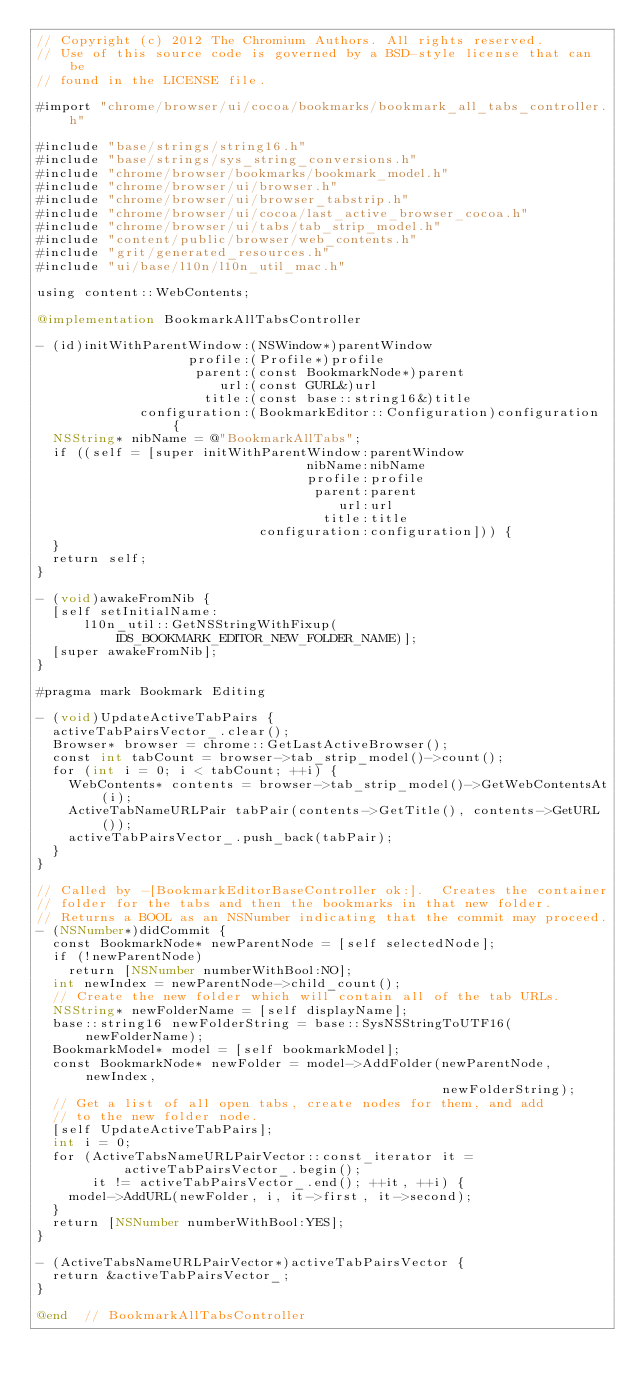<code> <loc_0><loc_0><loc_500><loc_500><_ObjectiveC_>// Copyright (c) 2012 The Chromium Authors. All rights reserved.
// Use of this source code is governed by a BSD-style license that can be
// found in the LICENSE file.

#import "chrome/browser/ui/cocoa/bookmarks/bookmark_all_tabs_controller.h"

#include "base/strings/string16.h"
#include "base/strings/sys_string_conversions.h"
#include "chrome/browser/bookmarks/bookmark_model.h"
#include "chrome/browser/ui/browser.h"
#include "chrome/browser/ui/browser_tabstrip.h"
#include "chrome/browser/ui/cocoa/last_active_browser_cocoa.h"
#include "chrome/browser/ui/tabs/tab_strip_model.h"
#include "content/public/browser/web_contents.h"
#include "grit/generated_resources.h"
#include "ui/base/l10n/l10n_util_mac.h"

using content::WebContents;

@implementation BookmarkAllTabsController

- (id)initWithParentWindow:(NSWindow*)parentWindow
                   profile:(Profile*)profile
                    parent:(const BookmarkNode*)parent
                       url:(const GURL&)url
                     title:(const base::string16&)title
             configuration:(BookmarkEditor::Configuration)configuration {
  NSString* nibName = @"BookmarkAllTabs";
  if ((self = [super initWithParentWindow:parentWindow
                                  nibName:nibName
                                  profile:profile
                                   parent:parent
                                      url:url
                                    title:title
                            configuration:configuration])) {
  }
  return self;
}

- (void)awakeFromNib {
  [self setInitialName:
      l10n_util::GetNSStringWithFixup(IDS_BOOKMARK_EDITOR_NEW_FOLDER_NAME)];
  [super awakeFromNib];
}

#pragma mark Bookmark Editing

- (void)UpdateActiveTabPairs {
  activeTabPairsVector_.clear();
  Browser* browser = chrome::GetLastActiveBrowser();
  const int tabCount = browser->tab_strip_model()->count();
  for (int i = 0; i < tabCount; ++i) {
    WebContents* contents = browser->tab_strip_model()->GetWebContentsAt(i);
    ActiveTabNameURLPair tabPair(contents->GetTitle(), contents->GetURL());
    activeTabPairsVector_.push_back(tabPair);
  }
}

// Called by -[BookmarkEditorBaseController ok:].  Creates the container
// folder for the tabs and then the bookmarks in that new folder.
// Returns a BOOL as an NSNumber indicating that the commit may proceed.
- (NSNumber*)didCommit {
  const BookmarkNode* newParentNode = [self selectedNode];
  if (!newParentNode)
    return [NSNumber numberWithBool:NO];
  int newIndex = newParentNode->child_count();
  // Create the new folder which will contain all of the tab URLs.
  NSString* newFolderName = [self displayName];
  base::string16 newFolderString = base::SysNSStringToUTF16(newFolderName);
  BookmarkModel* model = [self bookmarkModel];
  const BookmarkNode* newFolder = model->AddFolder(newParentNode, newIndex,
                                                   newFolderString);
  // Get a list of all open tabs, create nodes for them, and add
  // to the new folder node.
  [self UpdateActiveTabPairs];
  int i = 0;
  for (ActiveTabsNameURLPairVector::const_iterator it =
           activeTabPairsVector_.begin();
       it != activeTabPairsVector_.end(); ++it, ++i) {
    model->AddURL(newFolder, i, it->first, it->second);
  }
  return [NSNumber numberWithBool:YES];
}

- (ActiveTabsNameURLPairVector*)activeTabPairsVector {
  return &activeTabPairsVector_;
}

@end  // BookmarkAllTabsController

</code> 